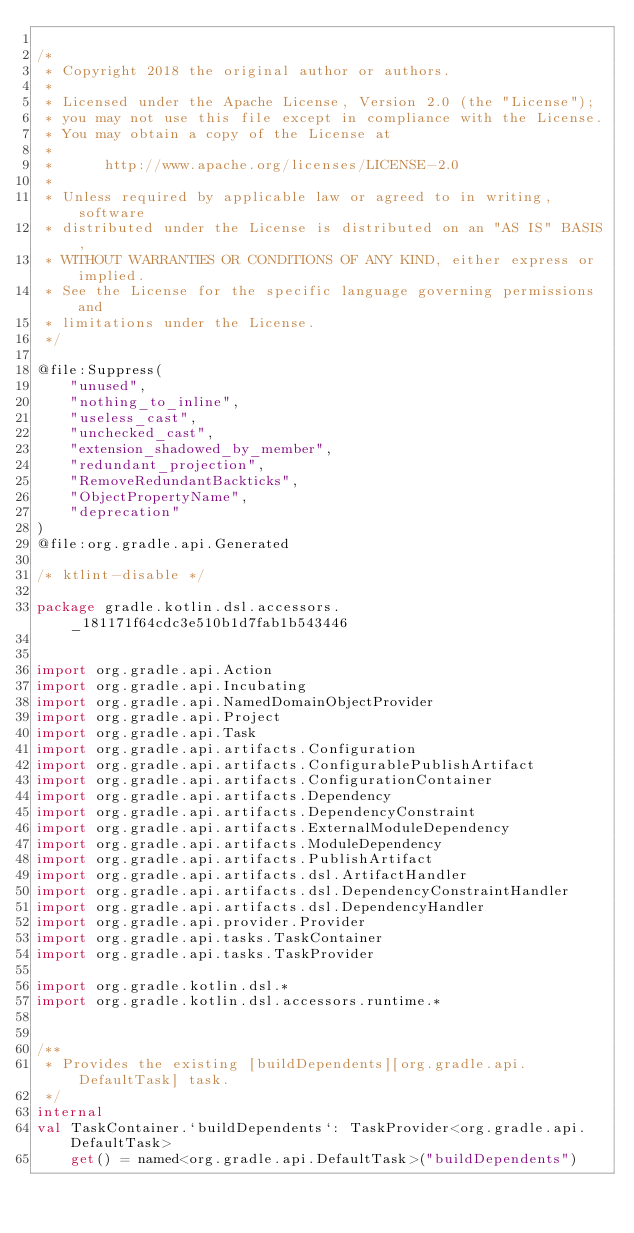Convert code to text. <code><loc_0><loc_0><loc_500><loc_500><_Kotlin_>
/*
 * Copyright 2018 the original author or authors.
 *
 * Licensed under the Apache License, Version 2.0 (the "License");
 * you may not use this file except in compliance with the License.
 * You may obtain a copy of the License at
 *
 *      http://www.apache.org/licenses/LICENSE-2.0
 *
 * Unless required by applicable law or agreed to in writing, software
 * distributed under the License is distributed on an "AS IS" BASIS,
 * WITHOUT WARRANTIES OR CONDITIONS OF ANY KIND, either express or implied.
 * See the License for the specific language governing permissions and
 * limitations under the License.
 */

@file:Suppress(
    "unused",
    "nothing_to_inline",
    "useless_cast",
    "unchecked_cast",
    "extension_shadowed_by_member",
    "redundant_projection",
    "RemoveRedundantBackticks",
    "ObjectPropertyName",
    "deprecation"
)
@file:org.gradle.api.Generated

/* ktlint-disable */

package gradle.kotlin.dsl.accessors._181171f64cdc3e510b1d7fab1b543446


import org.gradle.api.Action
import org.gradle.api.Incubating
import org.gradle.api.NamedDomainObjectProvider
import org.gradle.api.Project
import org.gradle.api.Task
import org.gradle.api.artifacts.Configuration
import org.gradle.api.artifacts.ConfigurablePublishArtifact
import org.gradle.api.artifacts.ConfigurationContainer
import org.gradle.api.artifacts.Dependency
import org.gradle.api.artifacts.DependencyConstraint
import org.gradle.api.artifacts.ExternalModuleDependency
import org.gradle.api.artifacts.ModuleDependency
import org.gradle.api.artifacts.PublishArtifact
import org.gradle.api.artifacts.dsl.ArtifactHandler
import org.gradle.api.artifacts.dsl.DependencyConstraintHandler
import org.gradle.api.artifacts.dsl.DependencyHandler
import org.gradle.api.provider.Provider
import org.gradle.api.tasks.TaskContainer
import org.gradle.api.tasks.TaskProvider

import org.gradle.kotlin.dsl.*
import org.gradle.kotlin.dsl.accessors.runtime.*


/**
 * Provides the existing [buildDependents][org.gradle.api.DefaultTask] task.
 */
internal
val TaskContainer.`buildDependents`: TaskProvider<org.gradle.api.DefaultTask>
    get() = named<org.gradle.api.DefaultTask>("buildDependents")


</code> 